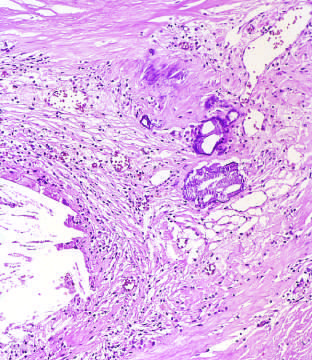what did high-power view of the junction of the fibrous cap and core show?
Answer the question using a single word or phrase. Scattered inflammatory cells 